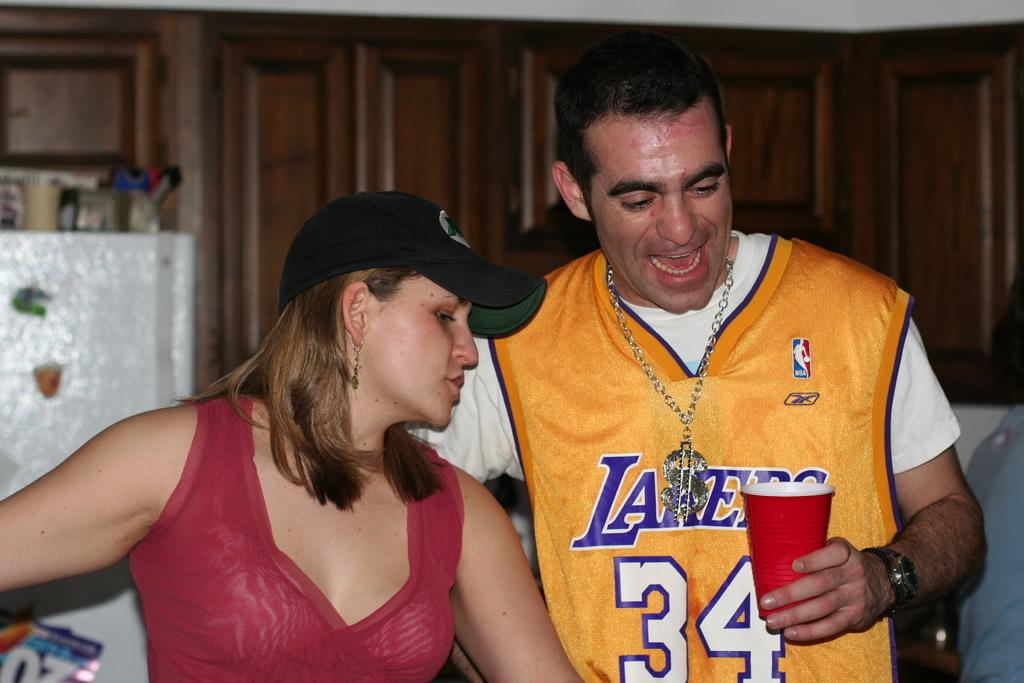<image>
Render a clear and concise summary of the photo. A man and a woman, the woman is in red and the man in yellow with a number 34 on his chest. 